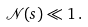Convert formula to latex. <formula><loc_0><loc_0><loc_500><loc_500>\mathcal { N } ( s ) \ll 1 \, .</formula> 